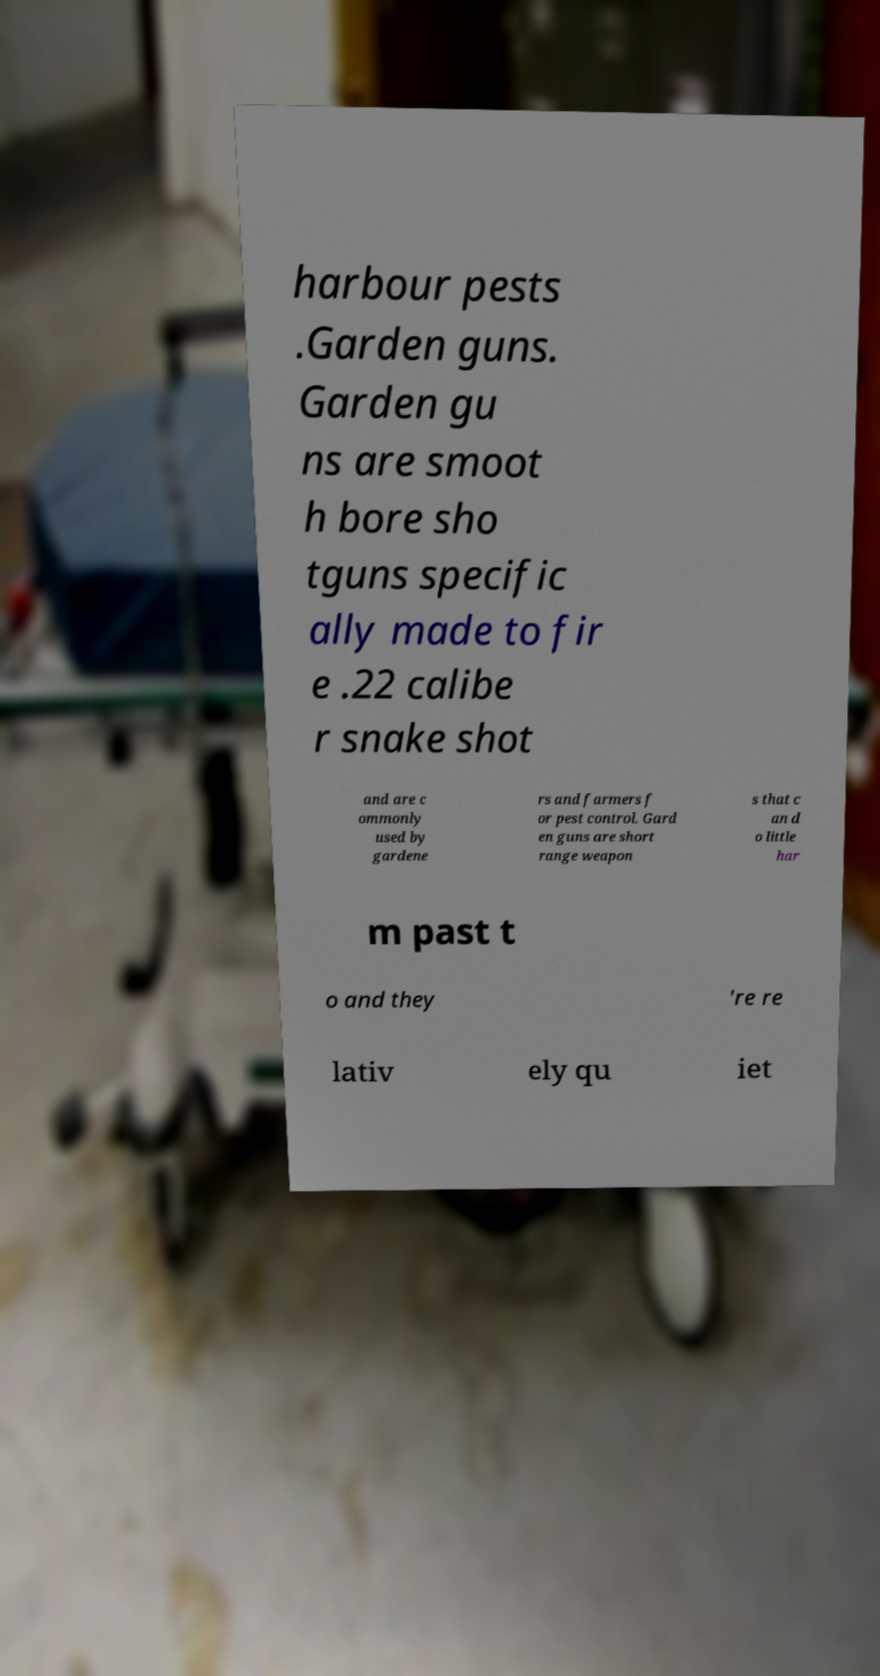There's text embedded in this image that I need extracted. Can you transcribe it verbatim? harbour pests .Garden guns. Garden gu ns are smoot h bore sho tguns specific ally made to fir e .22 calibe r snake shot and are c ommonly used by gardene rs and farmers f or pest control. Gard en guns are short range weapon s that c an d o little har m past t o and they 're re lativ ely qu iet 